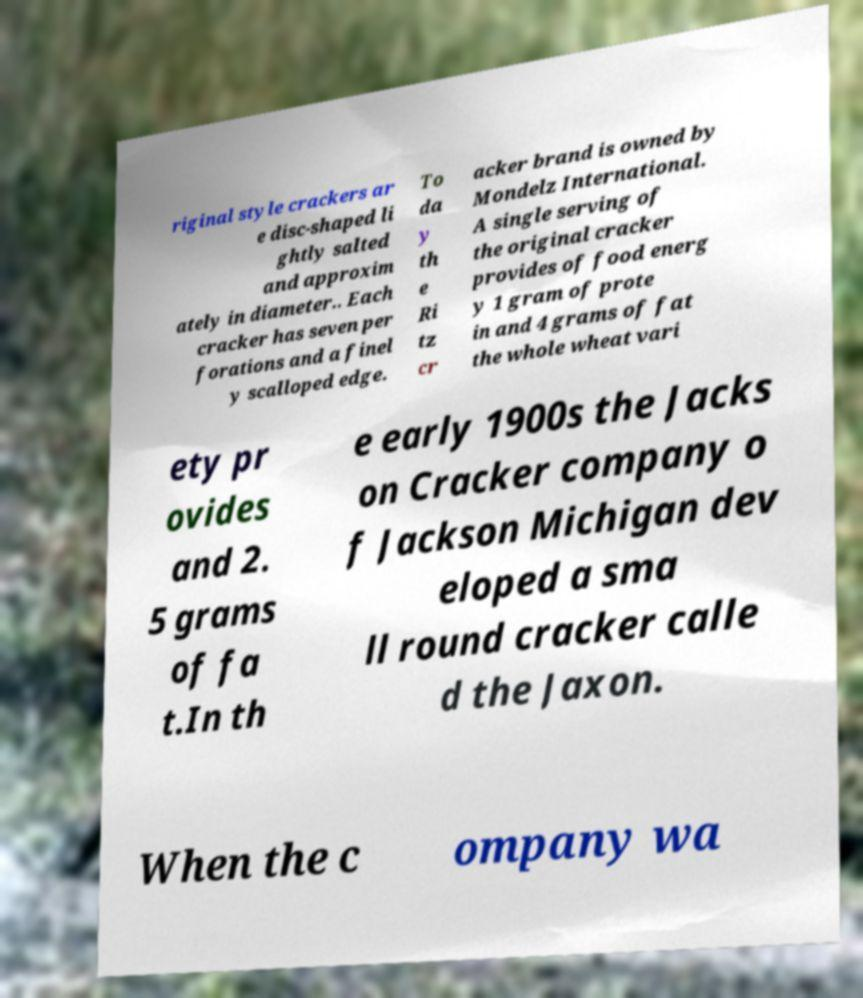Please identify and transcribe the text found in this image. riginal style crackers ar e disc-shaped li ghtly salted and approxim ately in diameter.. Each cracker has seven per forations and a finel y scalloped edge. To da y th e Ri tz cr acker brand is owned by Mondelz International. A single serving of the original cracker provides of food energ y 1 gram of prote in and 4 grams of fat the whole wheat vari ety pr ovides and 2. 5 grams of fa t.In th e early 1900s the Jacks on Cracker company o f Jackson Michigan dev eloped a sma ll round cracker calle d the Jaxon. When the c ompany wa 